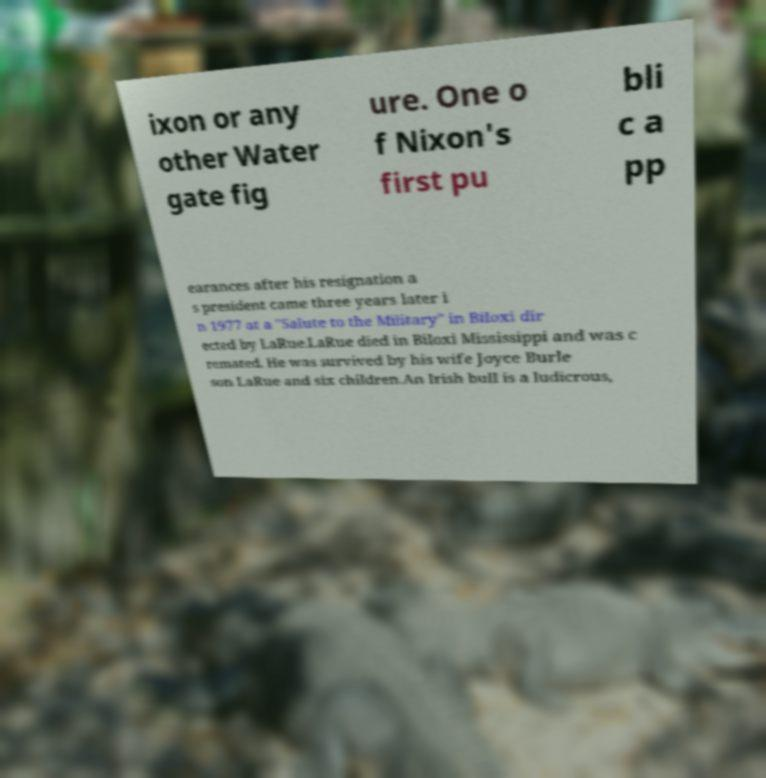For documentation purposes, I need the text within this image transcribed. Could you provide that? ixon or any other Water gate fig ure. One o f Nixon's first pu bli c a pp earances after his resignation a s president came three years later i n 1977 at a "Salute to the Military" in Biloxi dir ected by LaRue.LaRue died in Biloxi Mississippi and was c remated. He was survived by his wife Joyce Burle son LaRue and six children.An Irish bull is a ludicrous, 